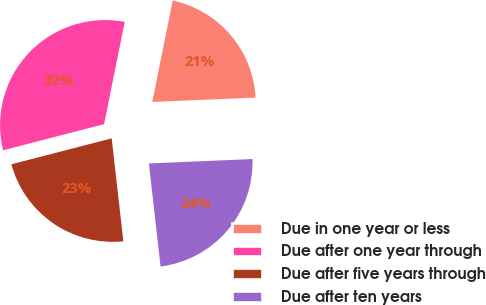<chart> <loc_0><loc_0><loc_500><loc_500><pie_chart><fcel>Due in one year or less<fcel>Due after one year through<fcel>Due after five years through<fcel>Due after ten years<nl><fcel>21.16%<fcel>32.2%<fcel>22.77%<fcel>23.88%<nl></chart> 